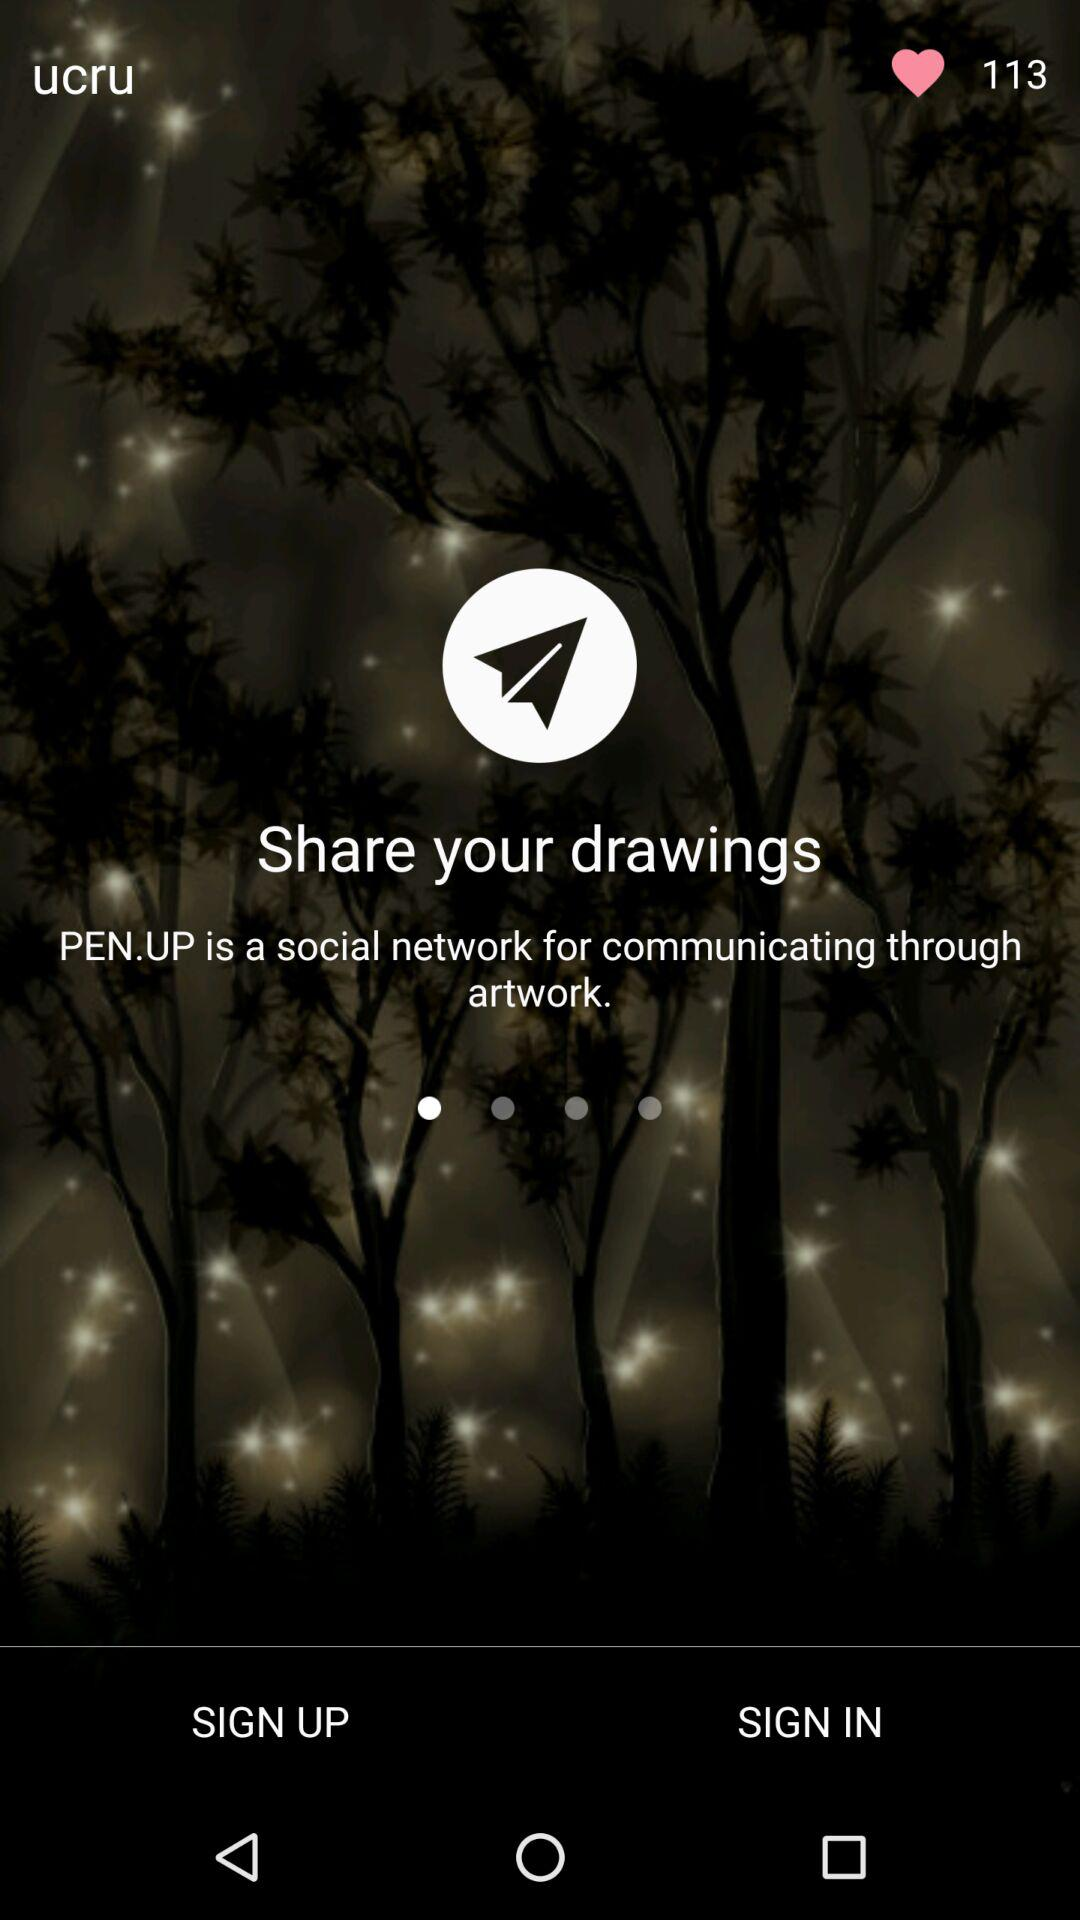What is the application name? The name of the application is "PEN.UP". 